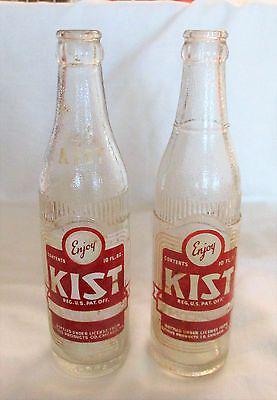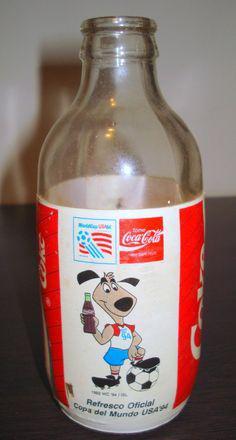The first image is the image on the left, the second image is the image on the right. Considering the images on both sides, is "All the bottles are filled with a dark liquid." valid? Answer yes or no. No. The first image is the image on the left, the second image is the image on the right. Given the left and right images, does the statement "There are two bottles in the image on the left and half that in the image on the right." hold true? Answer yes or no. Yes. 